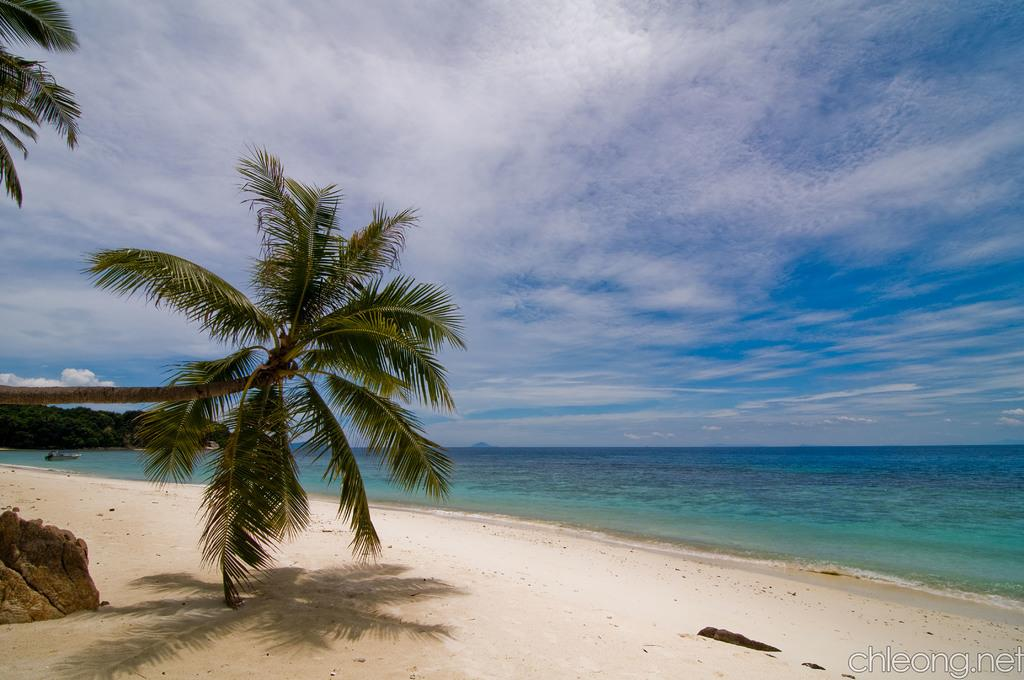What type of natural environment is depicted in the image? There is a seashore in the image. What can be seen in the distance behind the seashore? There is a sea visible in the background of the image. What is located on the left side of the image? There is a rock on the left side of the image. What type of vegetation is visible in the background of the image? There are trees in the background of the image. Where is the text located in the image? The text is in the bottom right corner of the image. How many apples are being used to make the pancake in the image? There is no pancake or apples present in the image; it features a seashore with a rock, trees, and text. 